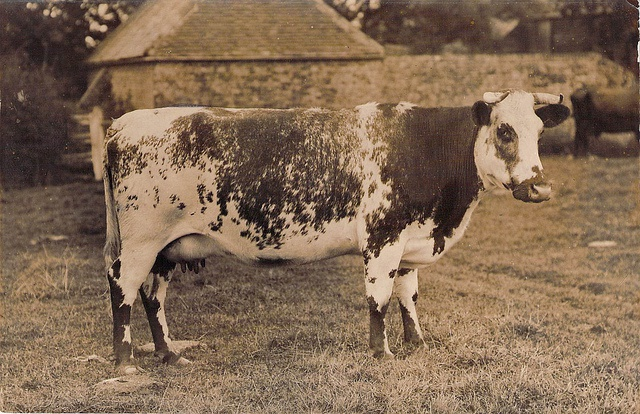Describe the objects in this image and their specific colors. I can see a cow in gray, tan, maroon, and black tones in this image. 